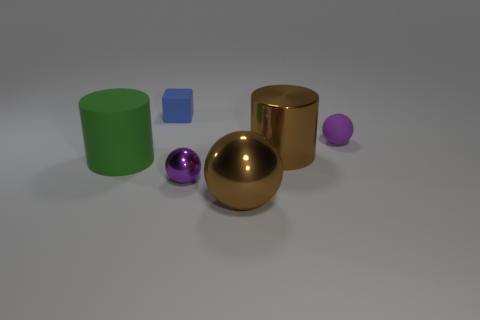Subtract all cyan spheres. Subtract all brown blocks. How many spheres are left? 3 Add 4 small cyan metallic blocks. How many objects exist? 10 Subtract all blocks. How many objects are left? 5 Subtract 0 gray cylinders. How many objects are left? 6 Subtract all tiny rubber cubes. Subtract all small purple shiny cylinders. How many objects are left? 5 Add 3 tiny metallic balls. How many tiny metallic balls are left? 4 Add 3 brown metallic things. How many brown metallic things exist? 5 